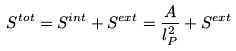<formula> <loc_0><loc_0><loc_500><loc_500>S ^ { t o t } = S ^ { i n t } + S ^ { e x t } = \frac { A } { l _ { P } ^ { 2 } } + S ^ { e x t }</formula> 